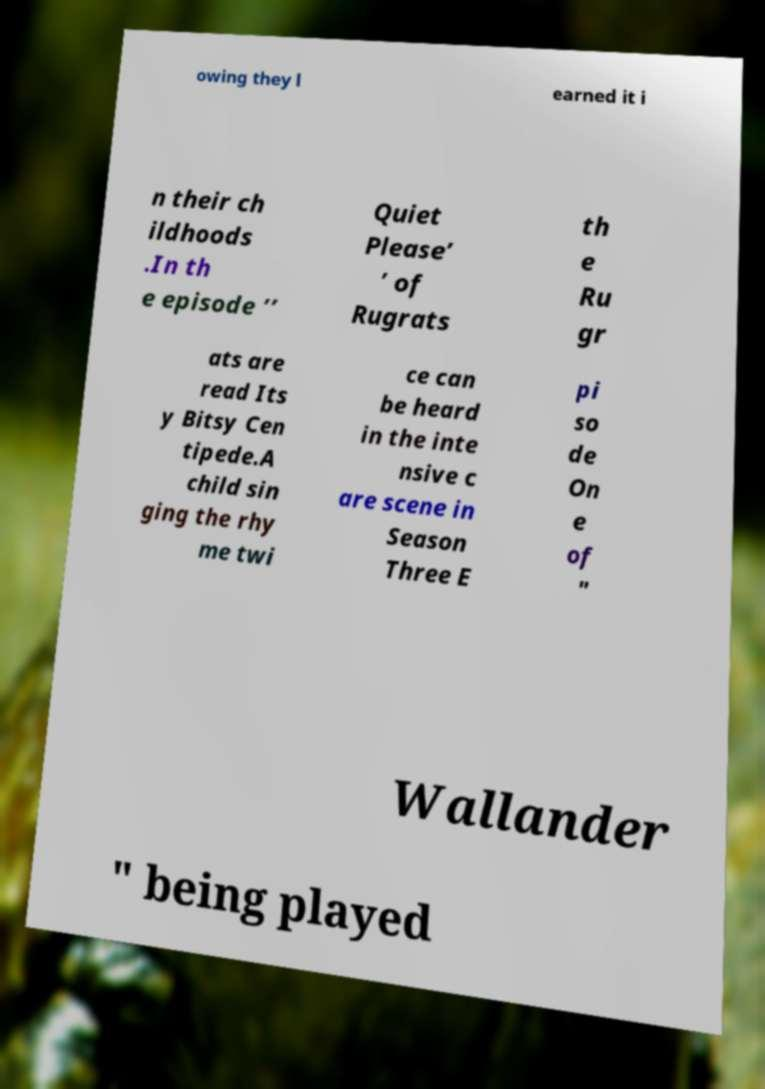Can you accurately transcribe the text from the provided image for me? owing they l earned it i n their ch ildhoods .In th e episode ’’ Quiet Please’ ’ of Rugrats th e Ru gr ats are read Its y Bitsy Cen tipede.A child sin ging the rhy me twi ce can be heard in the inte nsive c are scene in Season Three E pi so de On e of " Wallander " being played 